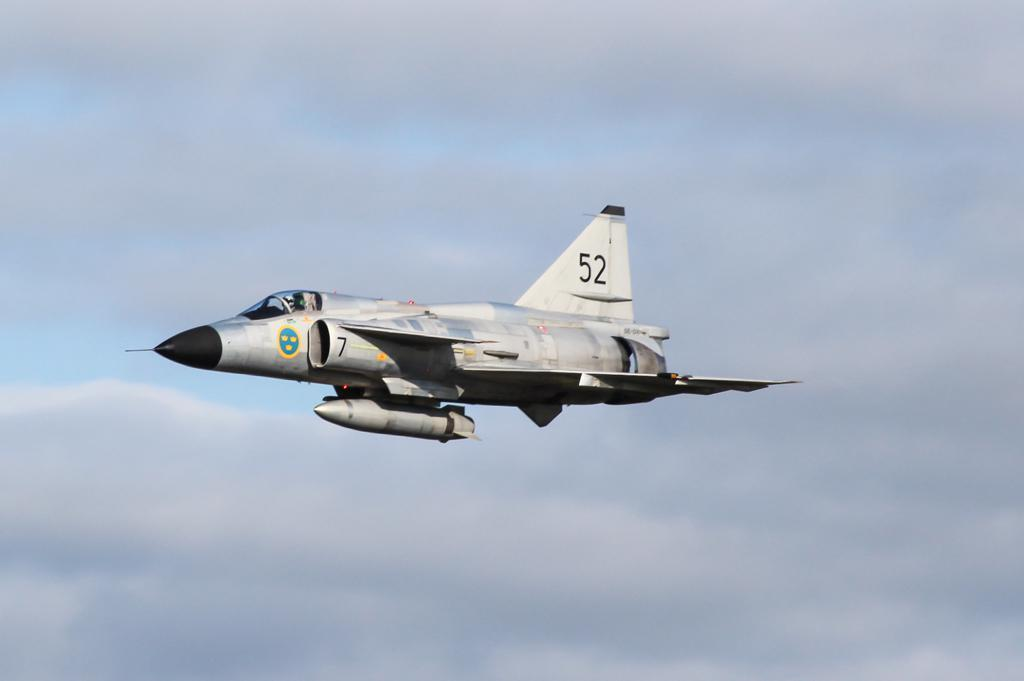<image>
Offer a succinct explanation of the picture presented. A fighter plane with the number 52 flies through the air 